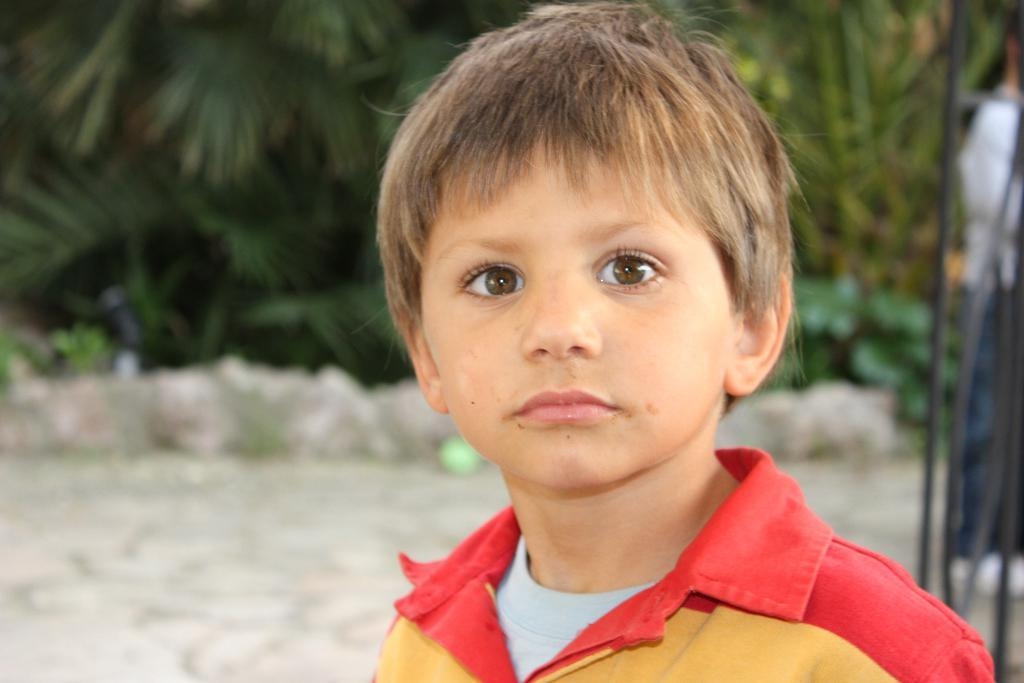What is the main subject of the picture? The main subject of the picture is a kid. What is the kid wearing in the picture? The kid is wearing a red and yellow color T-shirt. What can be seen in the background of the picture? There are trees in the background of the picture. What type of substance is the kid smelling in the picture? There is no indication in the image that the kid is smelling any substance, so it cannot be determined from the picture. 